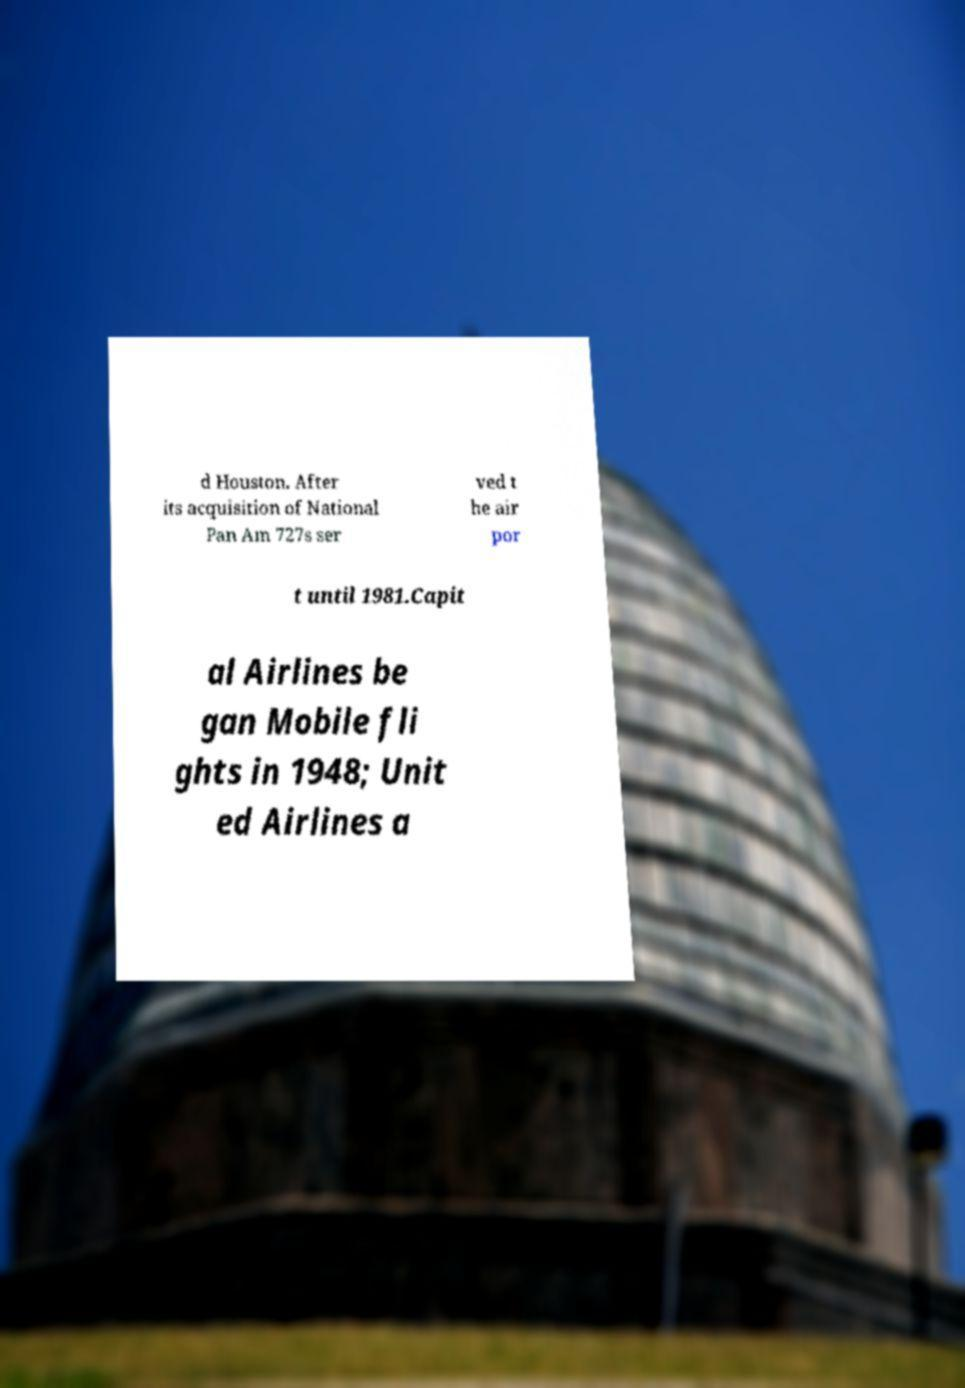For documentation purposes, I need the text within this image transcribed. Could you provide that? d Houston. After its acquisition of National Pan Am 727s ser ved t he air por t until 1981.Capit al Airlines be gan Mobile fli ghts in 1948; Unit ed Airlines a 